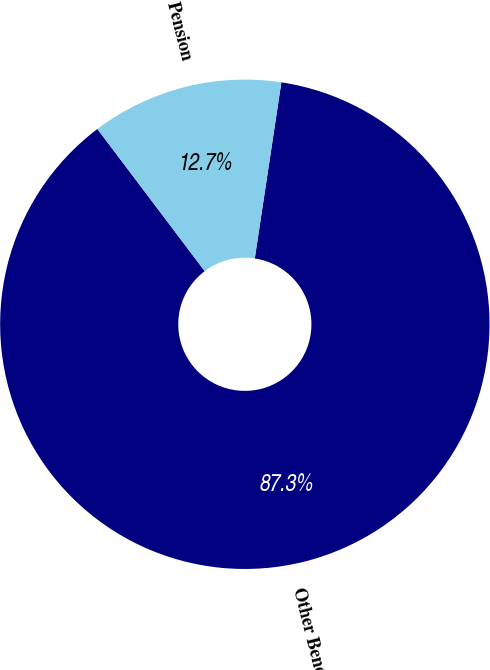Convert chart to OTSL. <chart><loc_0><loc_0><loc_500><loc_500><pie_chart><fcel>Other Benefits<fcel>Pension<nl><fcel>87.32%<fcel>12.68%<nl></chart> 